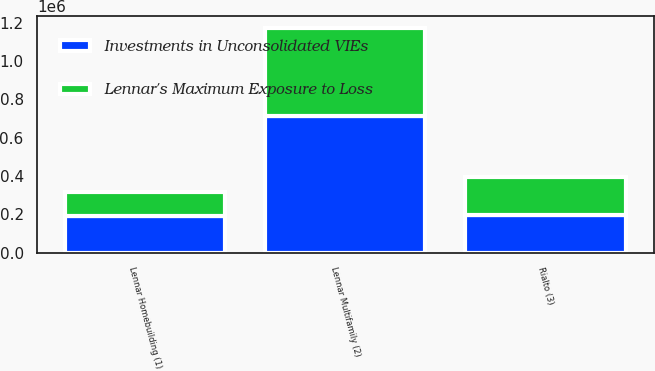Convert chart to OTSL. <chart><loc_0><loc_0><loc_500><loc_500><stacked_bar_chart><ecel><fcel>Lennar Homebuilding (1)<fcel>Lennar Multifamily (2)<fcel>Rialto (3)<nl><fcel>Lennar's Maximum Exposure to Loss<fcel>127009<fcel>463534<fcel>196956<nl><fcel>Investments in Unconsolidated VIEs<fcel>188890<fcel>710754<fcel>196956<nl></chart> 